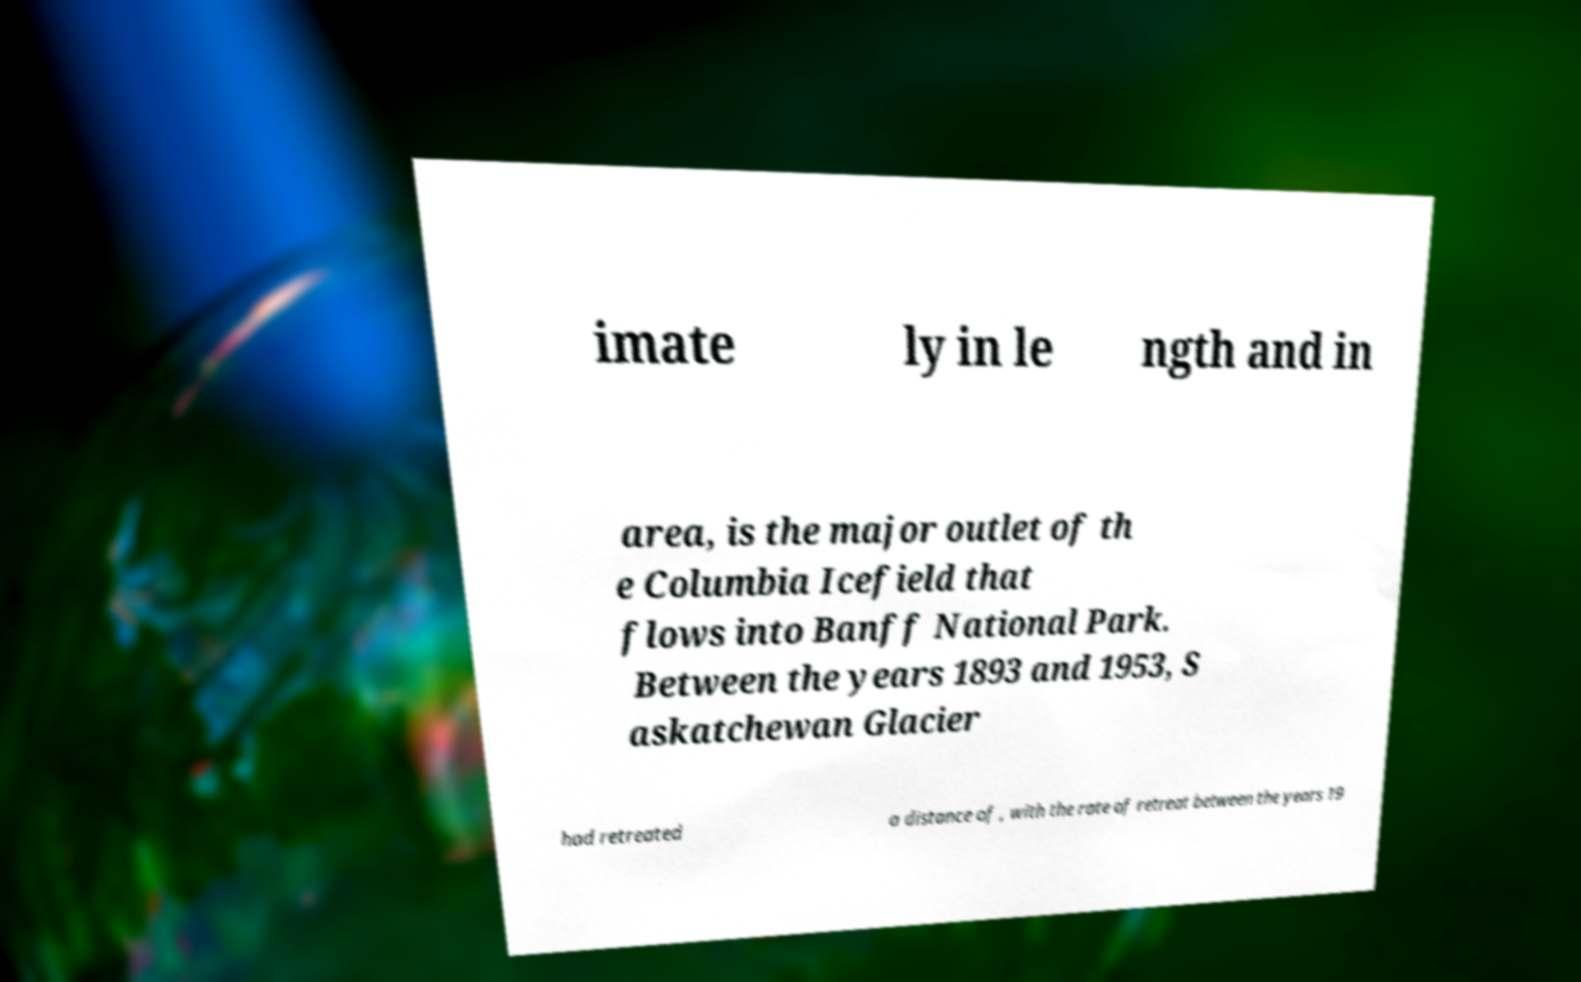For documentation purposes, I need the text within this image transcribed. Could you provide that? imate ly in le ngth and in area, is the major outlet of th e Columbia Icefield that flows into Banff National Park. Between the years 1893 and 1953, S askatchewan Glacier had retreated a distance of , with the rate of retreat between the years 19 